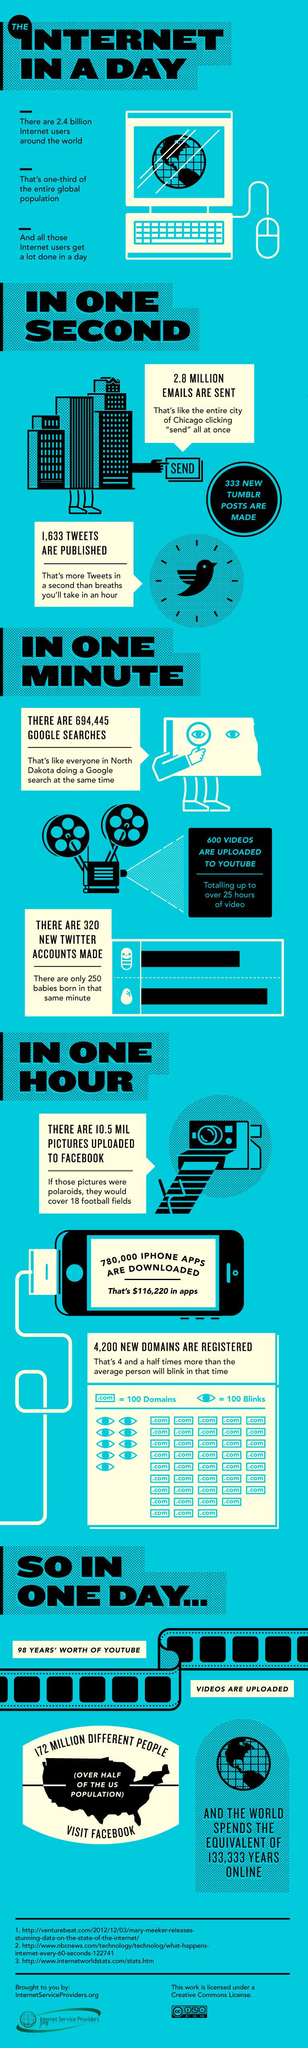Give some essential details in this illustration. According to recent studies, one-third of the global population uses the internet. Three sources are listed. 